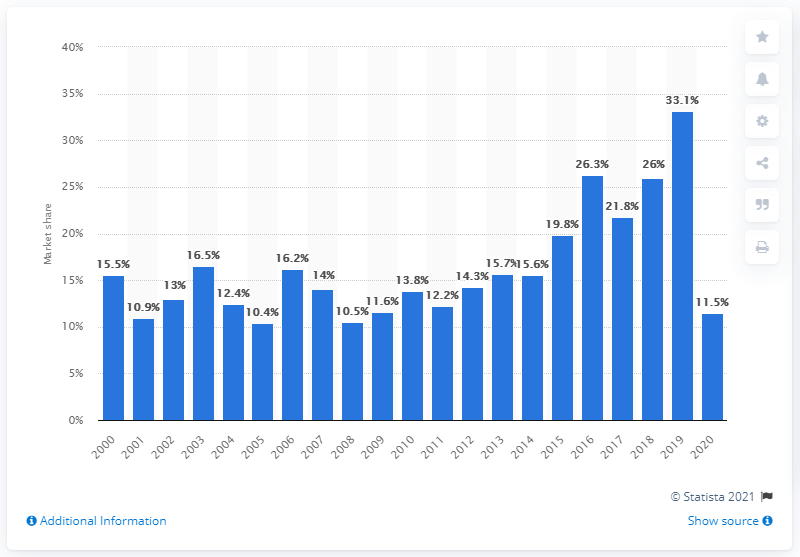Give some essential details in this illustration. In 2020, Disney's releases accounted for approximately 11.5% of all earnings at the box office in North America. Disney's box office earnings in the previous year were 33.1. 